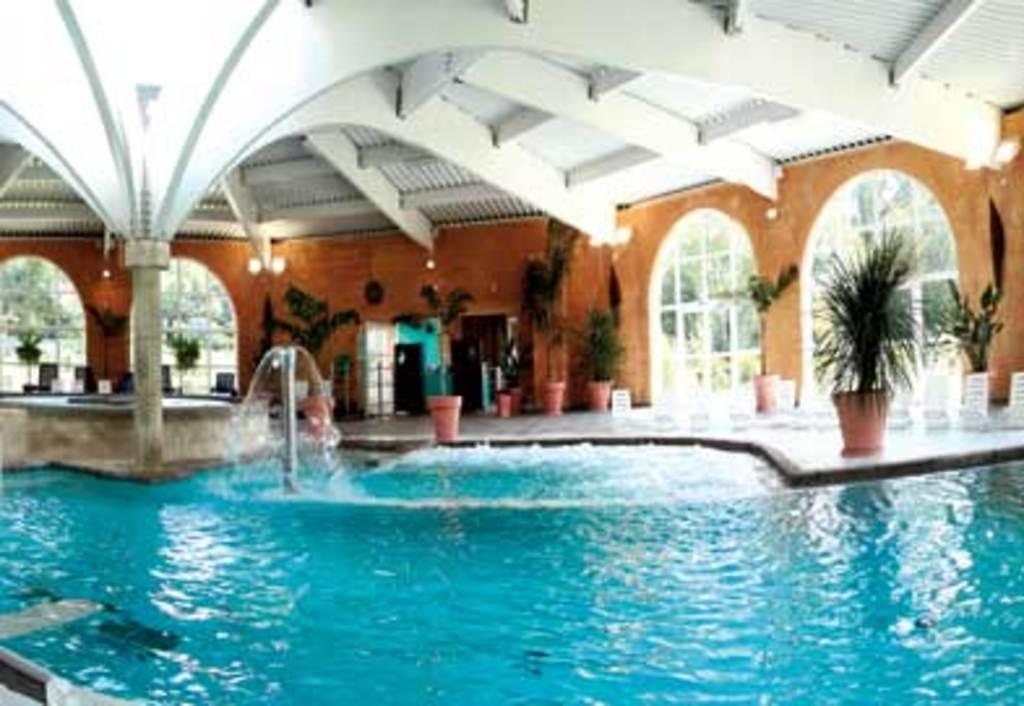How would you summarize this image in a sentence or two? In this picture we can see a swimming pool. There is a rod. We can see some house plants. There are a few lights and arches are seen on the wall. We can see a few trees in the background. 